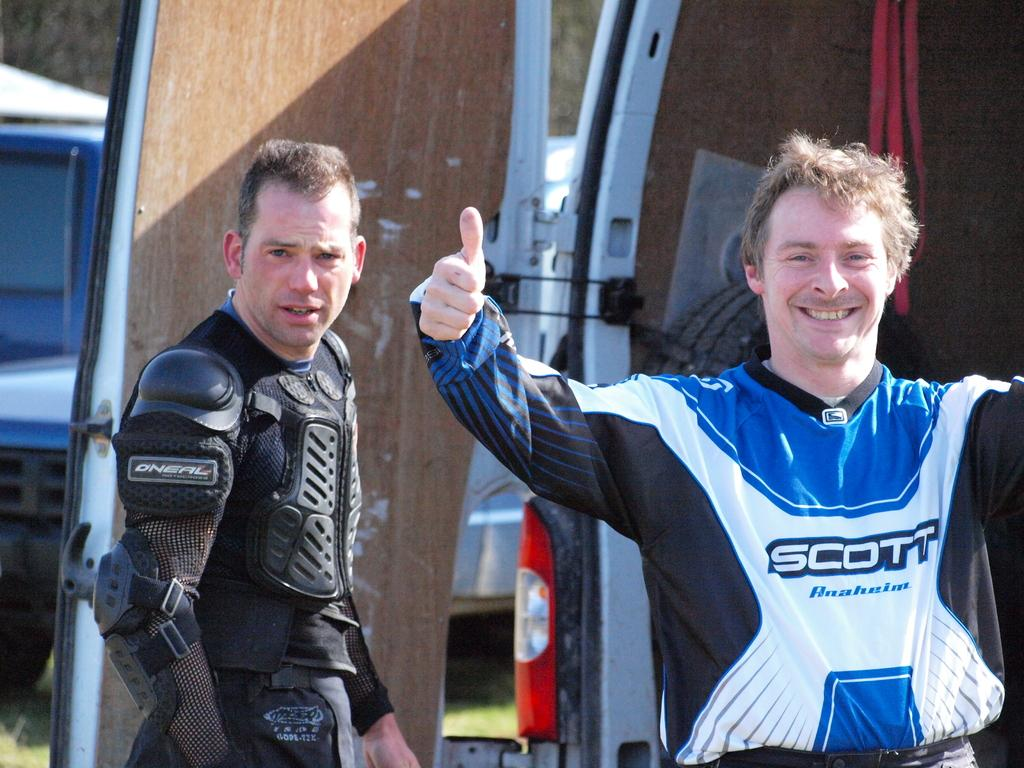<image>
Provide a brief description of the given image. two men with sports clothes on, one says Scott. 